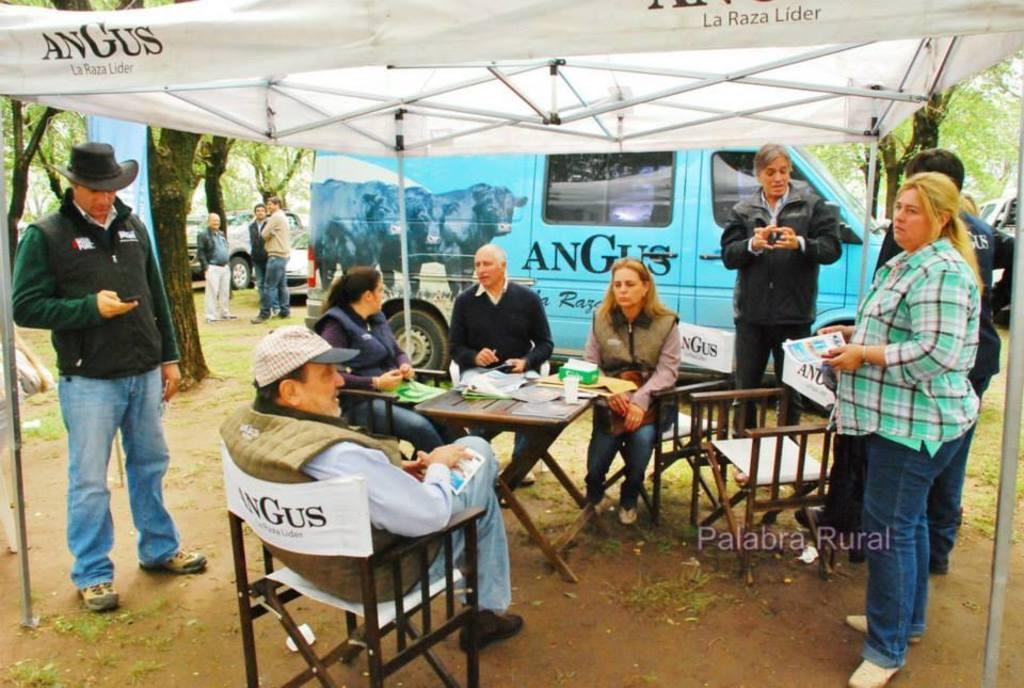How would you summarize this image in a sentence or two? This is a picture taken in the outdoor, there are a group of people sitting on a chair in front of the people there is a table on the table there is a paper, bottle, cloth and some people are standing on the floor. On top of them there is a tent. background of this people there is a van which is in blue color. There are three people standing on the left side of the van. 